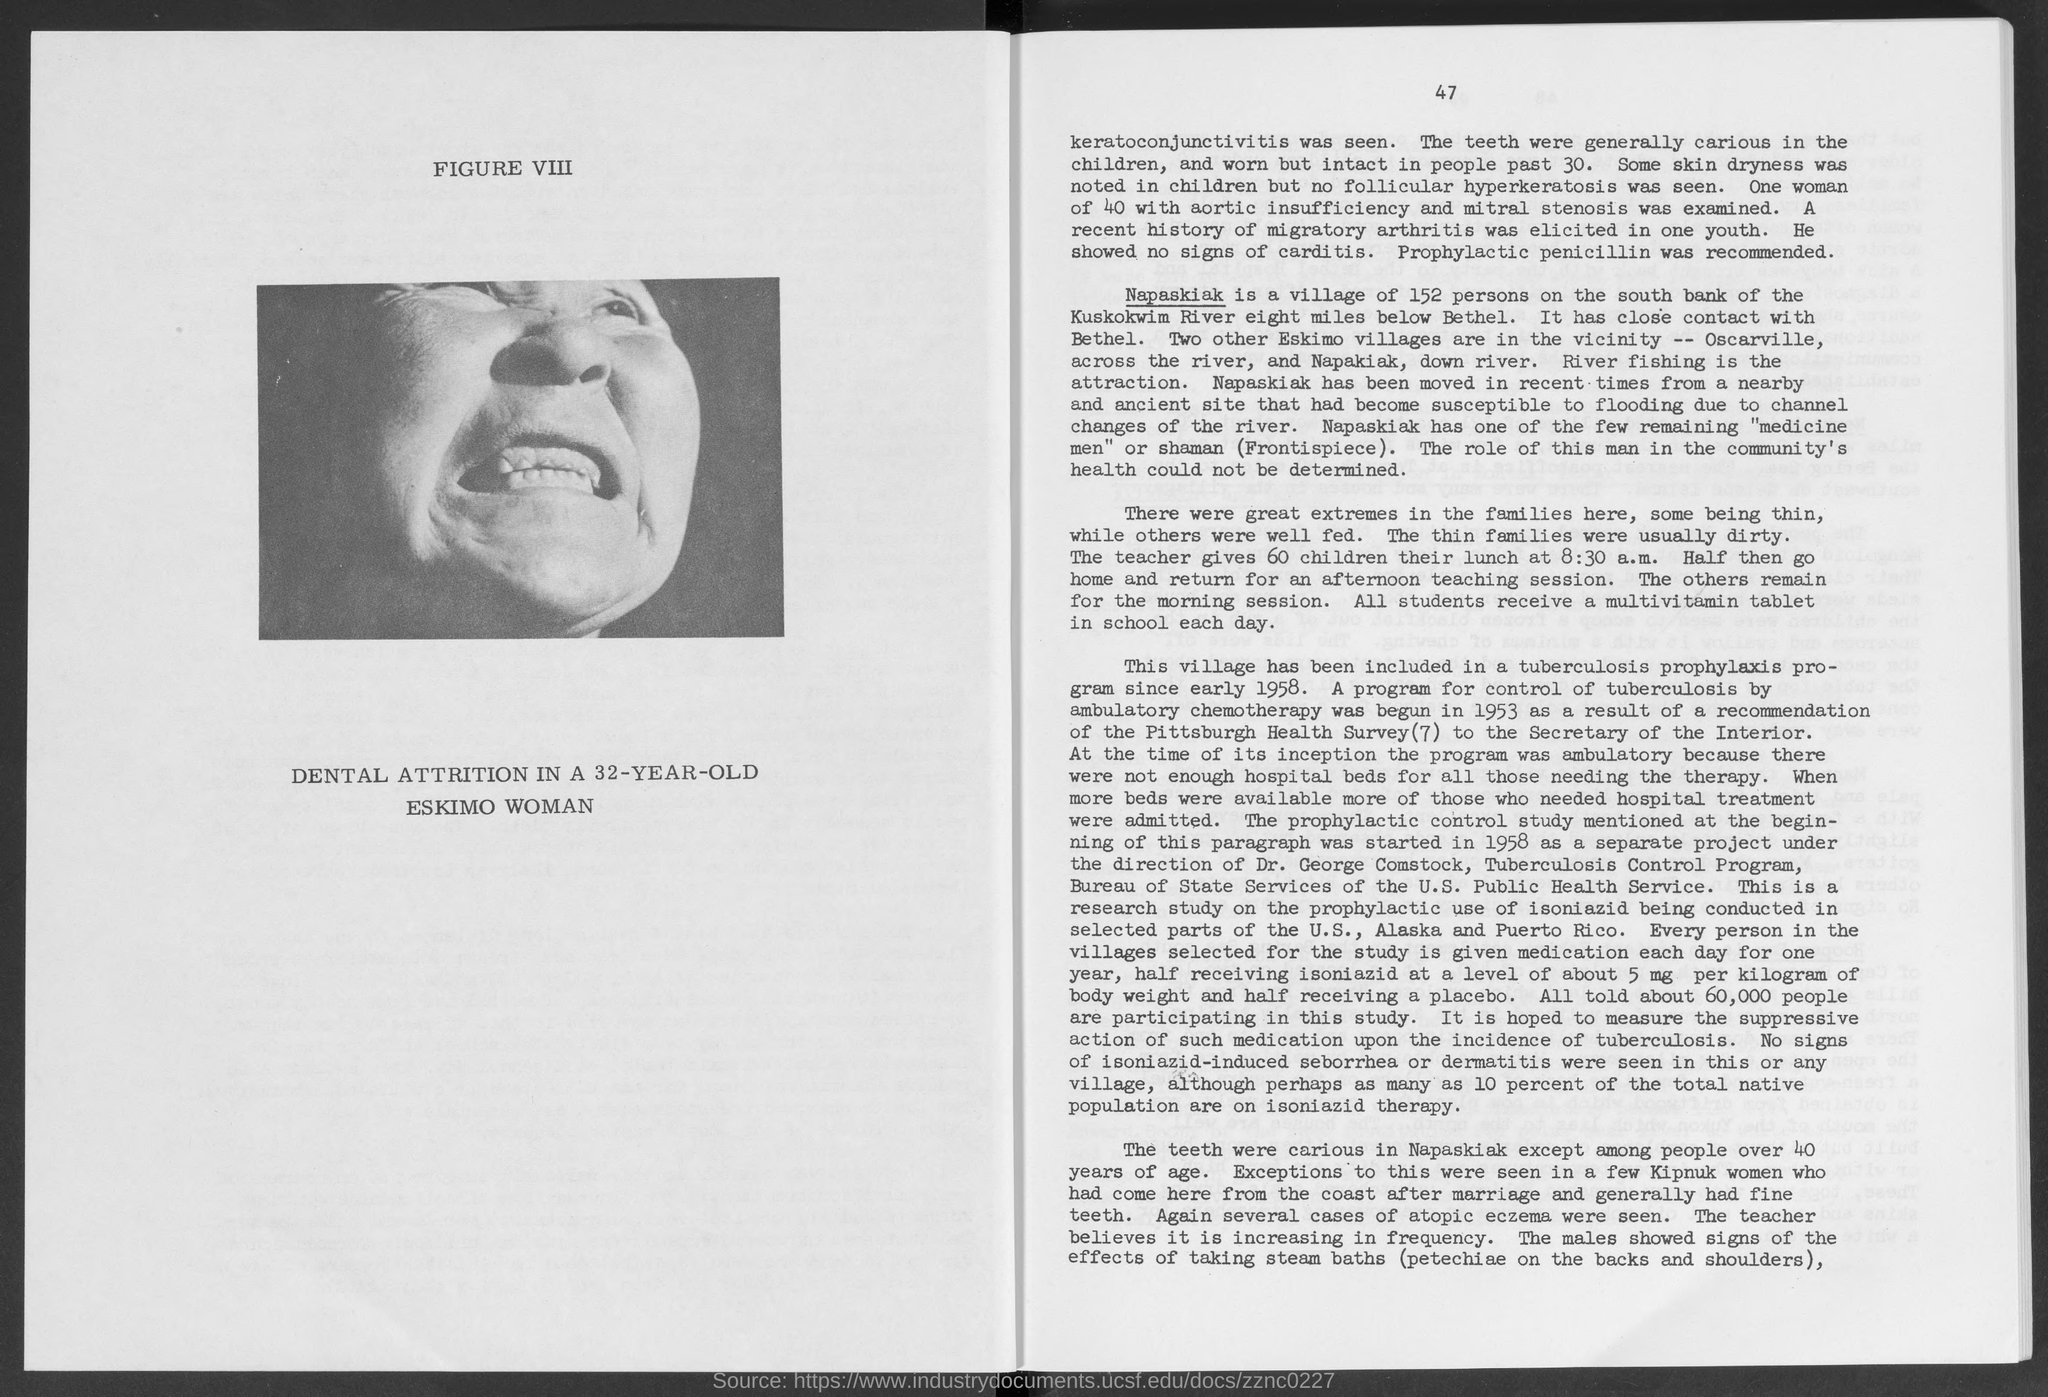What is written above the picture?
Provide a succinct answer. Figure viii. What is written below the picture/ photograph?
Make the answer very short. Dental attrition in a 32-year-old eskimo woman. What is the time mentioned in the third paragraph?
Offer a terse response. 8:30 a.m. 